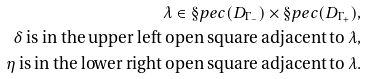Convert formula to latex. <formula><loc_0><loc_0><loc_500><loc_500>\lambda \in \S p e c ( D _ { \Gamma _ { - } } ) \times \S p e c ( D _ { \Gamma _ { + } } ) , \\ \delta \text { is in the upper left open square adjacent to } \lambda , \\ \eta \text { is in the lower right open square adjacent to } \lambda .</formula> 